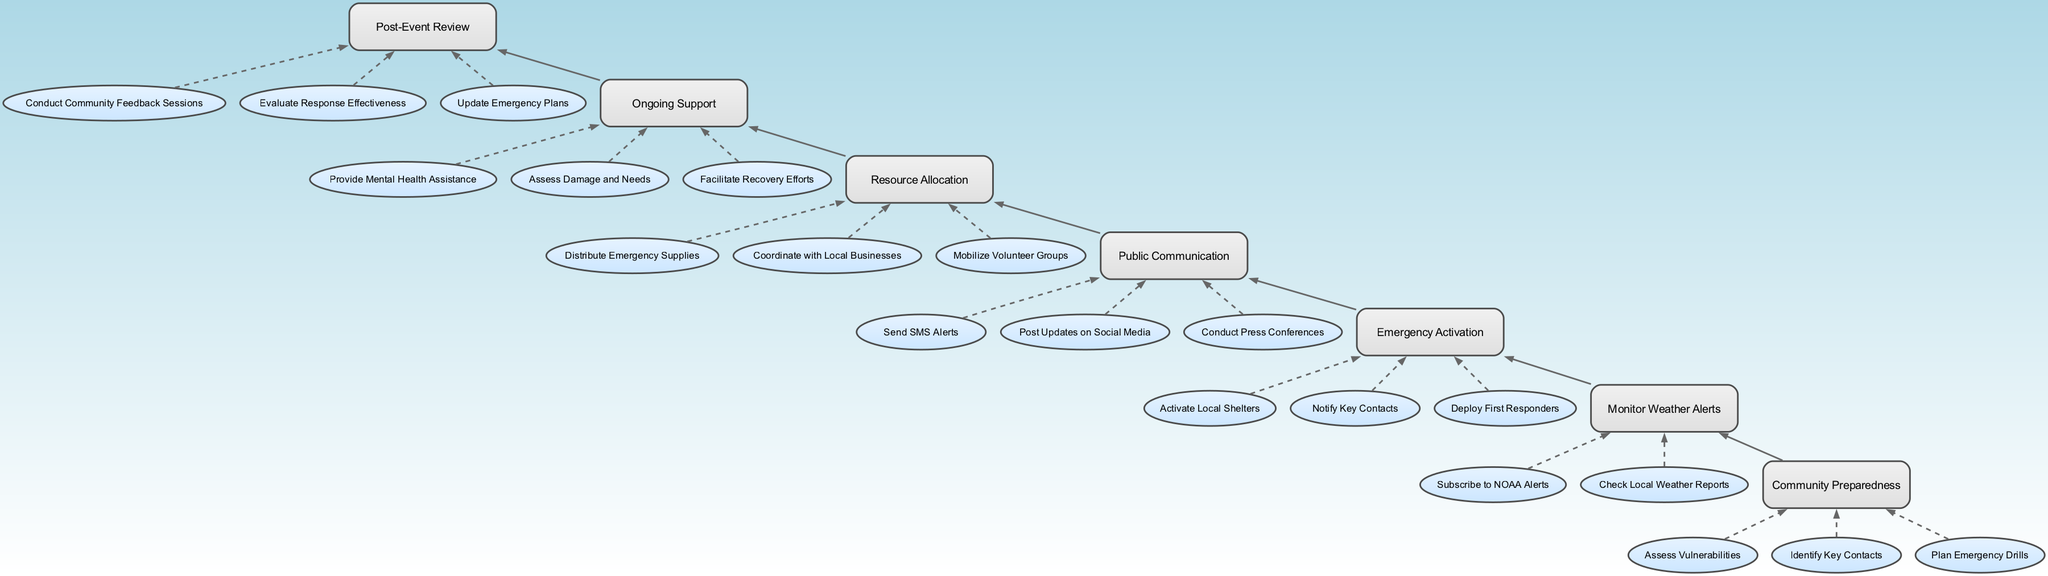What is the top node of the diagram? The top node represents the initial stage of the community support network activation during severe weather, which is "Community Preparedness". This can be found as the first element in the list.
Answer: Community Preparedness How many actions are listed under "Resource Allocation"? By reviewing the "Resource Allocation" node in the diagram, we can see it has three actions listed below it: "Distribute Emergency Supplies", "Coordinate with Local Businesses", and "Mobilize Volunteer Groups". Thus, the count is three.
Answer: 3 Which node comes after "Monitor Weather Alerts"? The diagram flows from bottom to top. After "Monitor Weather Alerts", the next node in the upward direction is "Emergency Activation". This can be determined by tracing the edges connecting these nodes.
Answer: Emergency Activation What actions are included in the "Public Communication" node? The "Public Communication" node contains three actions listed below it: "Send SMS Alerts", "Post Updates on Social Media", and "Conduct Press Conferences". Each action is directly tied to the public communication process during emergencies.
Answer: Send SMS Alerts, Post Updates on Social Media, Conduct Press Conferences What is the last node after "Ongoing Support"? The last node in the diagram, which comes after "Ongoing Support", is "Post-Event Review". This can be established by following the upward flow to see what comes sequentially after the ongoing support stage.
Answer: Post-Event Review Which node precedes "Emergency Activation"? In the upward flow of the diagram, the node that comes directly before "Emergency Activation" is "Monitor Weather Alerts". This is determined by the connection of their edges in the flowchart.
Answer: Monitor Weather Alerts How many total nodes are depicted in the diagram? There are a total of seven nodes depicted in the diagram, including all the stages from "Community Preparedness" to "Post-Event Review". This count can be verified by counting each of the distinct nodes illustrated.
Answer: 7 What is the first action listed under "Community Preparedness"? The first action under the "Community Preparedness" node is "Assess Vulnerabilities". This is seen as the first item in the actions list corresponding to that node.
Answer: Assess Vulnerabilities What type of actions does "Ongoing Support" focus on? The "Ongoing Support" node is highlighted by actions that focus on providing assistance: "Provide Mental Health Assistance", "Assess Damage and Needs", and "Facilitate Recovery Efforts". This shows a supportive role after the immediate response.
Answer: Provide Mental Health Assistance, Assess Damage and Needs, Facilitate Recovery Efforts 